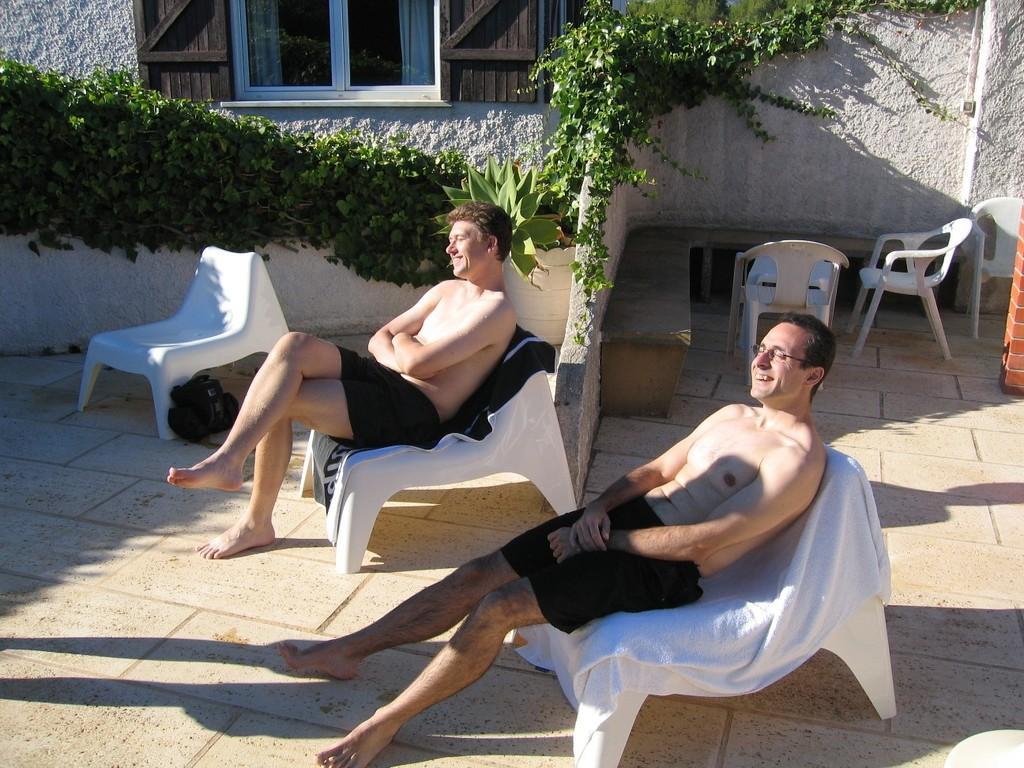Describe this image in one or two sentences. Here we can see two people are sitting on the chair and smiling, and at side here are the climbers, and here are the chairs, and here is the wall, and here is the window. 